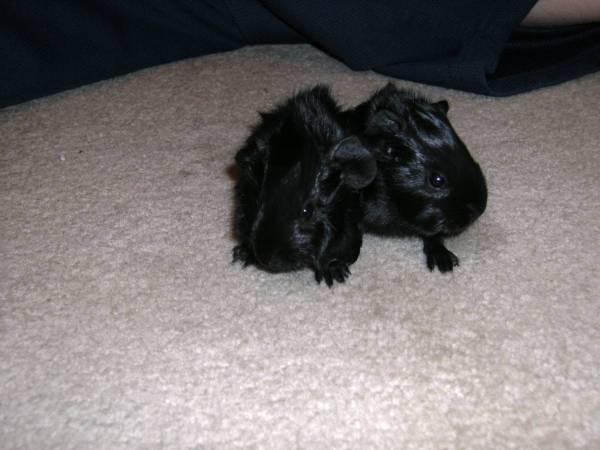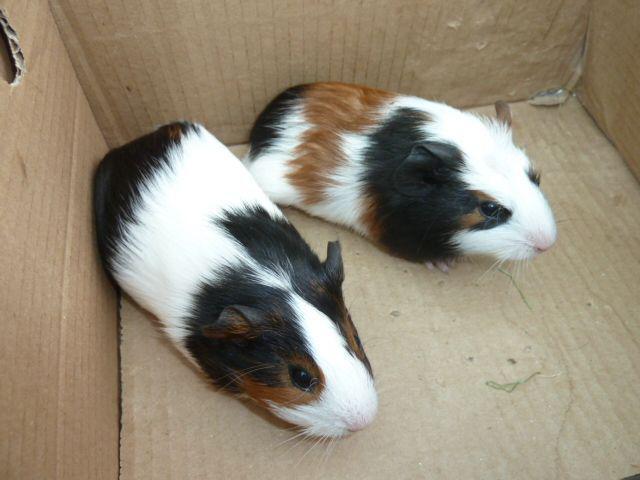The first image is the image on the left, the second image is the image on the right. Considering the images on both sides, is "The right image has two guinea pigs." valid? Answer yes or no. Yes. The first image is the image on the left, the second image is the image on the right. For the images shown, is this caption "there is at least one guinea pig in a cardboard box" true? Answer yes or no. Yes. 